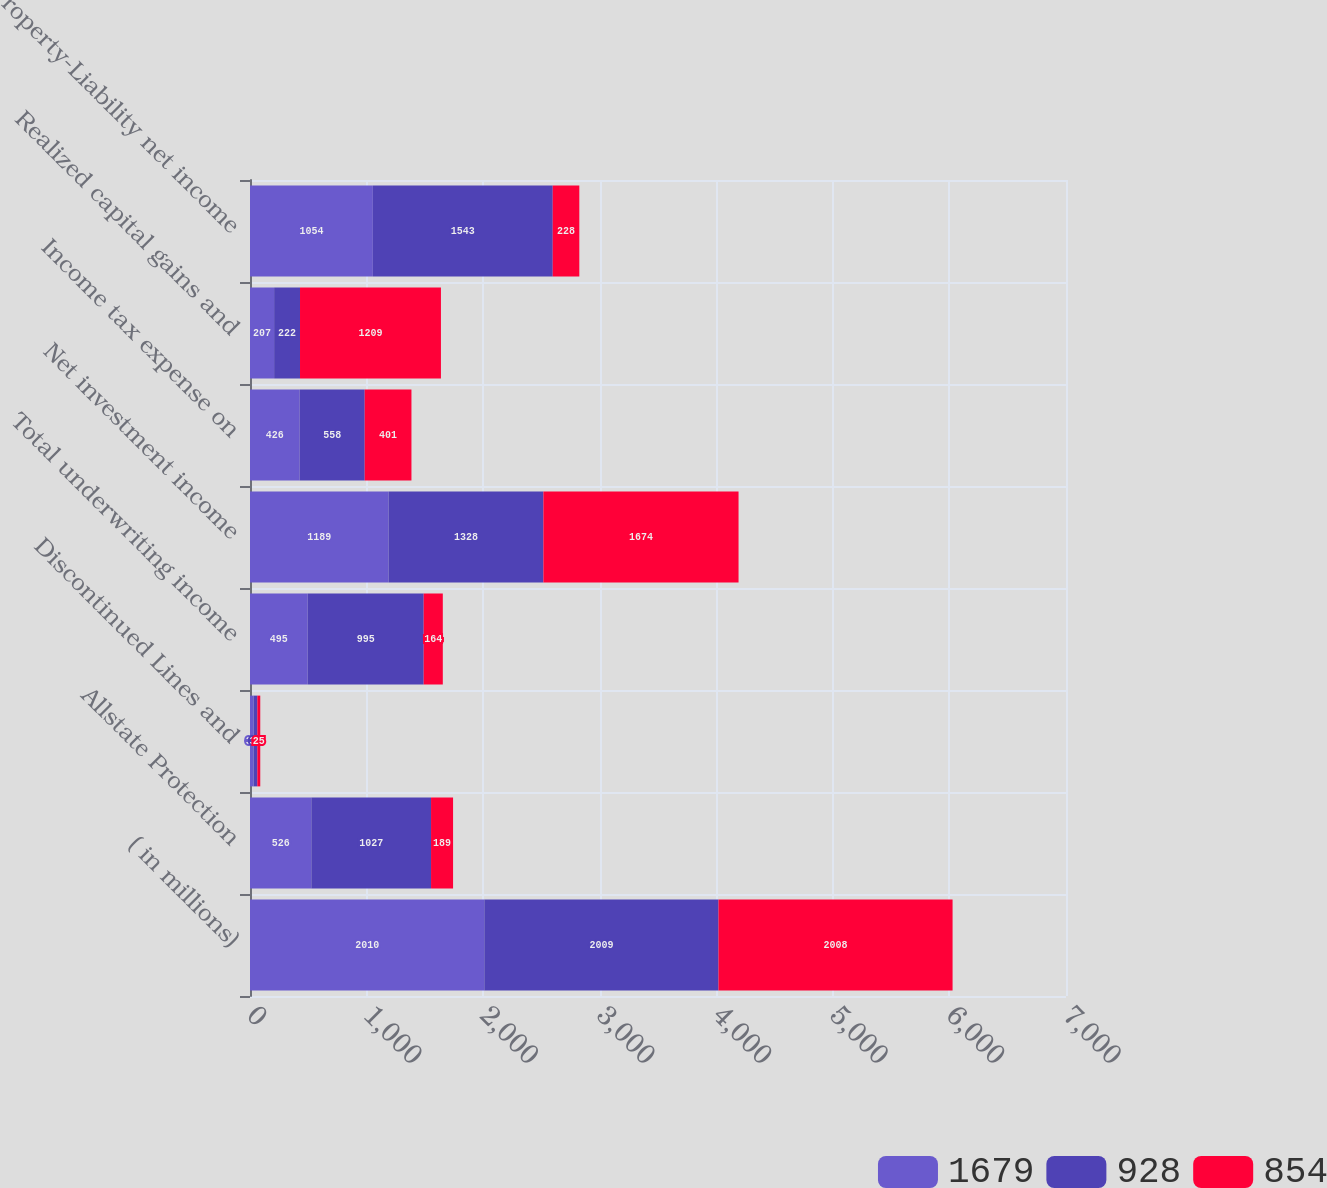Convert chart. <chart><loc_0><loc_0><loc_500><loc_500><stacked_bar_chart><ecel><fcel>( in millions)<fcel>Allstate Protection<fcel>Discontinued Lines and<fcel>Total underwriting income<fcel>Net investment income<fcel>Income tax expense on<fcel>Realized capital gains and<fcel>Property-Liability net income<nl><fcel>1679<fcel>2010<fcel>526<fcel>31<fcel>495<fcel>1189<fcel>426<fcel>207<fcel>1054<nl><fcel>928<fcel>2009<fcel>1027<fcel>32<fcel>995<fcel>1328<fcel>558<fcel>222<fcel>1543<nl><fcel>854<fcel>2008<fcel>189<fcel>25<fcel>164<fcel>1674<fcel>401<fcel>1209<fcel>228<nl></chart> 